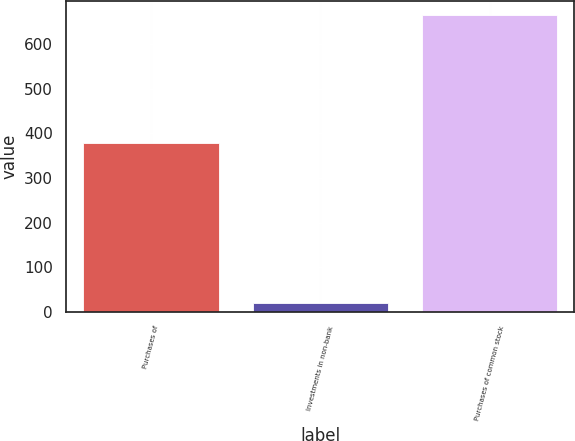Convert chart to OTSL. <chart><loc_0><loc_0><loc_500><loc_500><bar_chart><fcel>Purchases of<fcel>Investments in non-bank<fcel>Purchases of common stock<nl><fcel>378<fcel>20<fcel>664<nl></chart> 